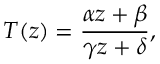<formula> <loc_0><loc_0><loc_500><loc_500>T ( z ) = { \frac { \alpha z + \beta } { \gamma z + \delta } } ,</formula> 